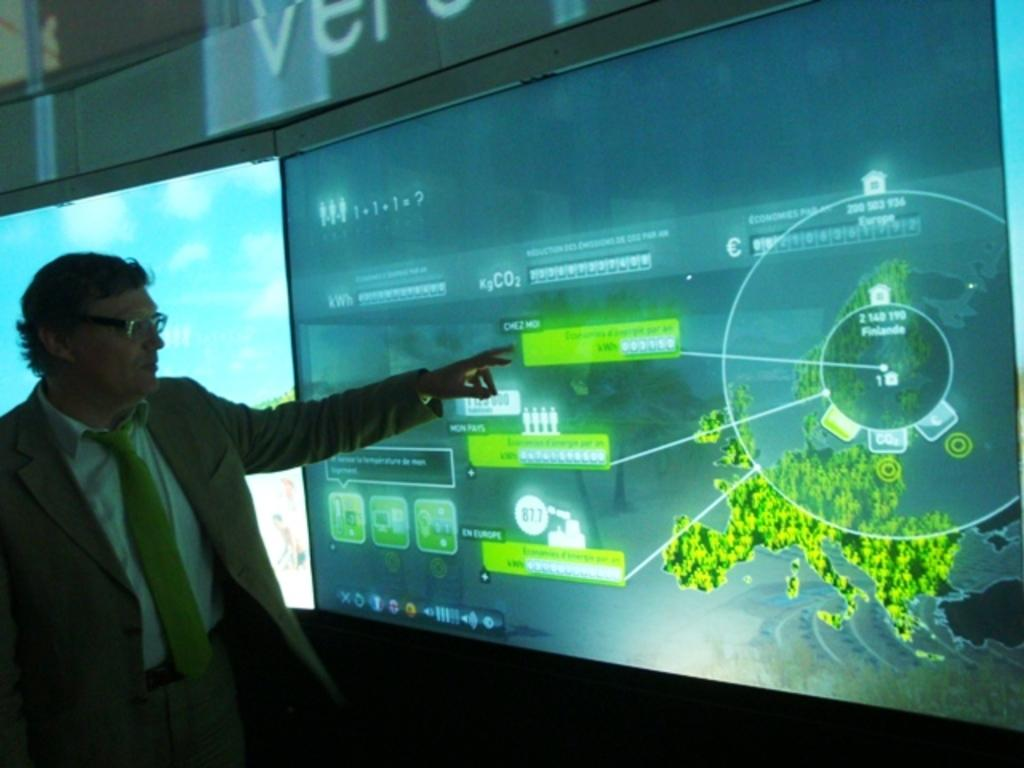Provide a one-sentence caption for the provided image. A 1+1+1=? equation is displayed on the top left of the projector screen. 